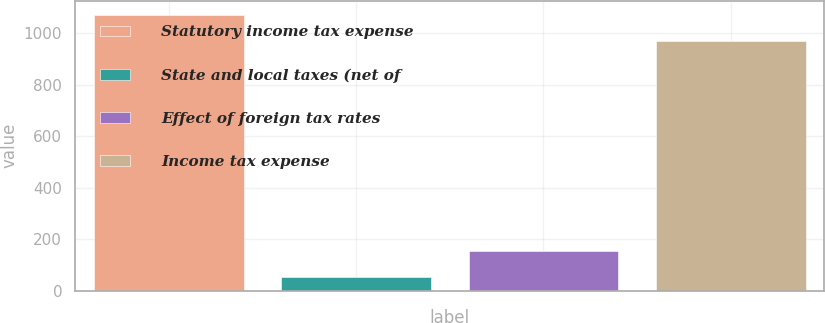Convert chart. <chart><loc_0><loc_0><loc_500><loc_500><bar_chart><fcel>Statutory income tax expense<fcel>State and local taxes (net of<fcel>Effect of foreign tax rates<fcel>Income tax expense<nl><fcel>1071.9<fcel>53<fcel>153.9<fcel>971<nl></chart> 